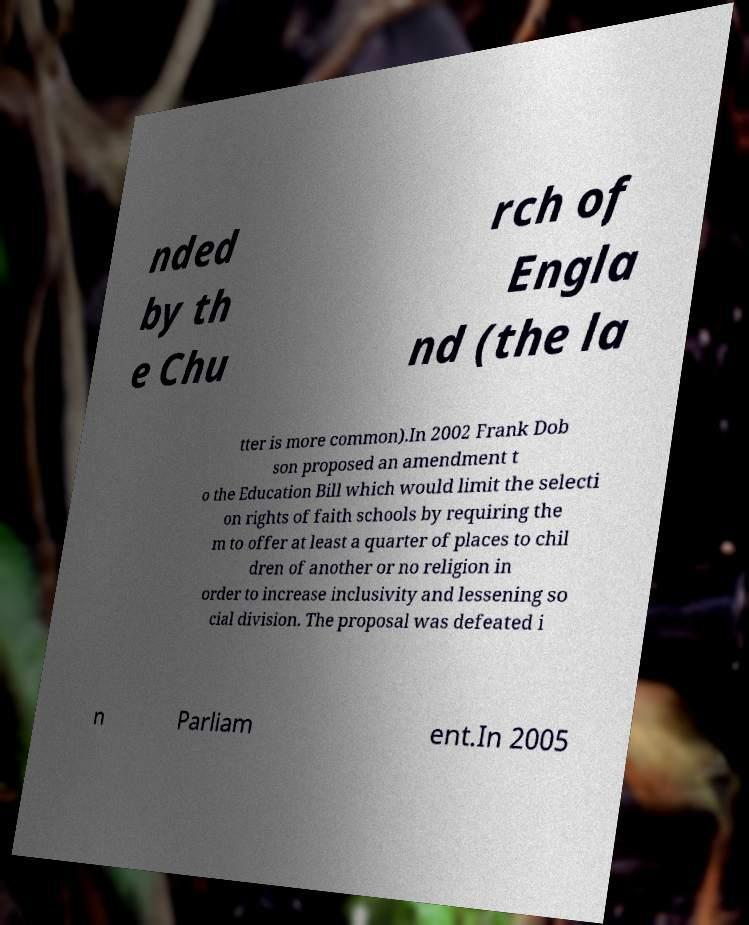Can you read and provide the text displayed in the image?This photo seems to have some interesting text. Can you extract and type it out for me? nded by th e Chu rch of Engla nd (the la tter is more common).In 2002 Frank Dob son proposed an amendment t o the Education Bill which would limit the selecti on rights of faith schools by requiring the m to offer at least a quarter of places to chil dren of another or no religion in order to increase inclusivity and lessening so cial division. The proposal was defeated i n Parliam ent.In 2005 